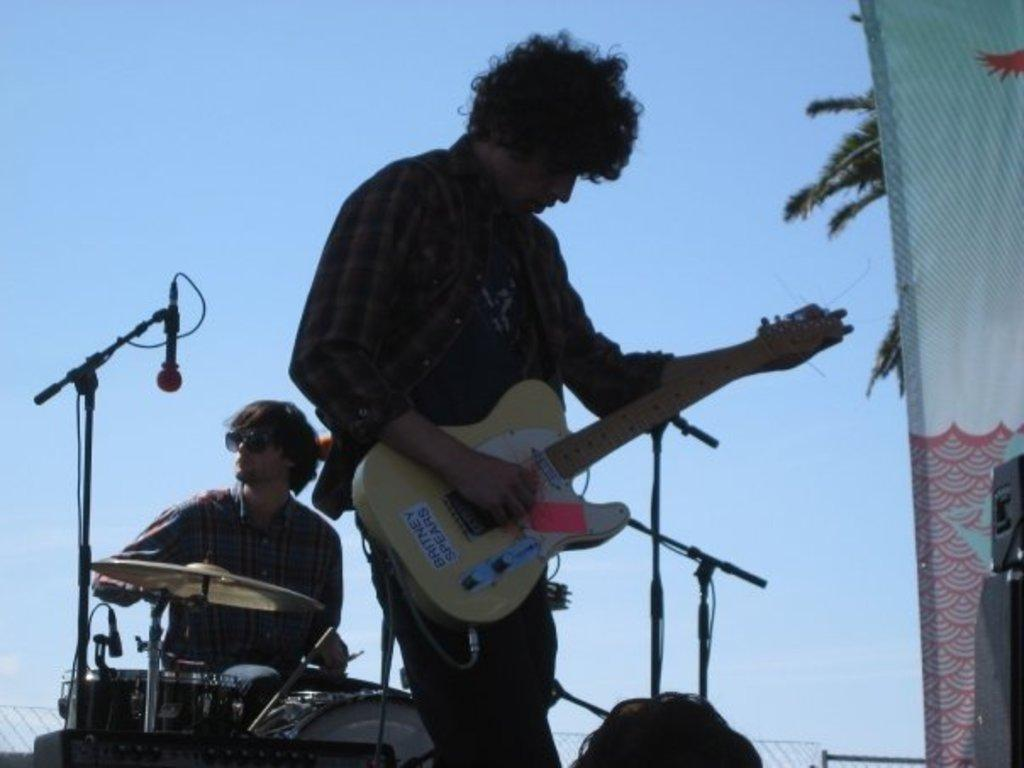Where was the image taken? The image is taken outdoors. How many people are in the image? There are two persons in the image. What are the two persons doing in the image? The two persons are on a stage and performing with music instruments. What can be seen in the background of the image? The background of the image is the sky. What type of insurance policy is being discussed by the two persons on the stage? There is no indication in the image that the two persons are discussing any insurance policies. 